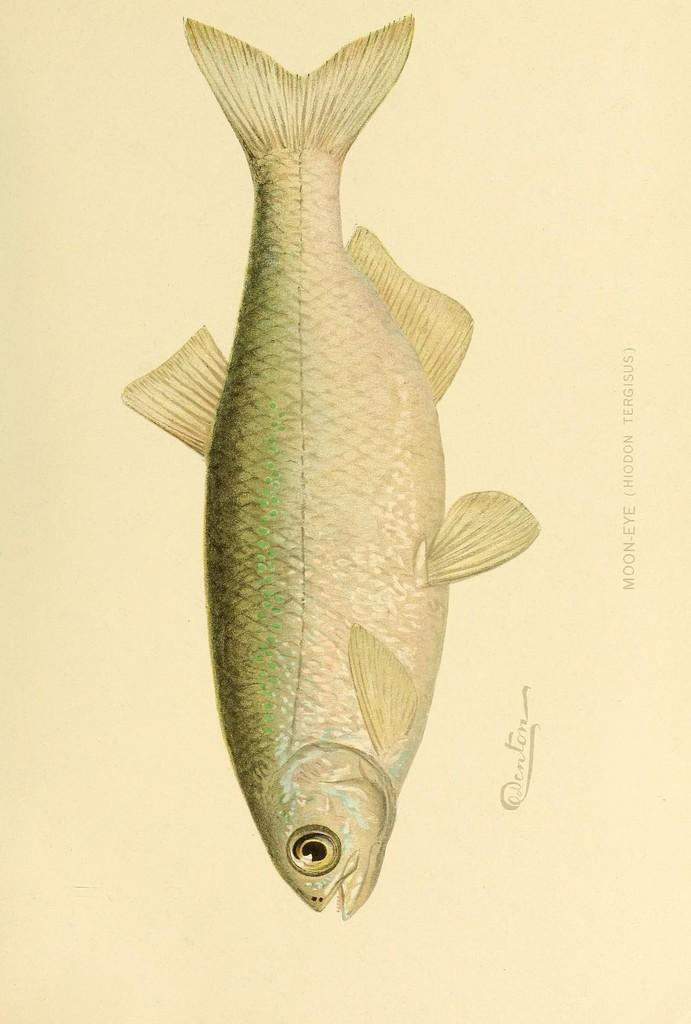What is depicted in the image? There is a sketch of a fish in the image. What is the color of the paper on which the sketch is drawn? The sketch is on cream color paper. What colors are used to create the fish in the sketch? The fish is in cream and green color. Are there any words visible in the image? Yes, there are words visible in the image. What type of curtain is hanging near the sketch in the image? There is no curtain present in the image; it only features a sketch of a fish on paper with visible words. 